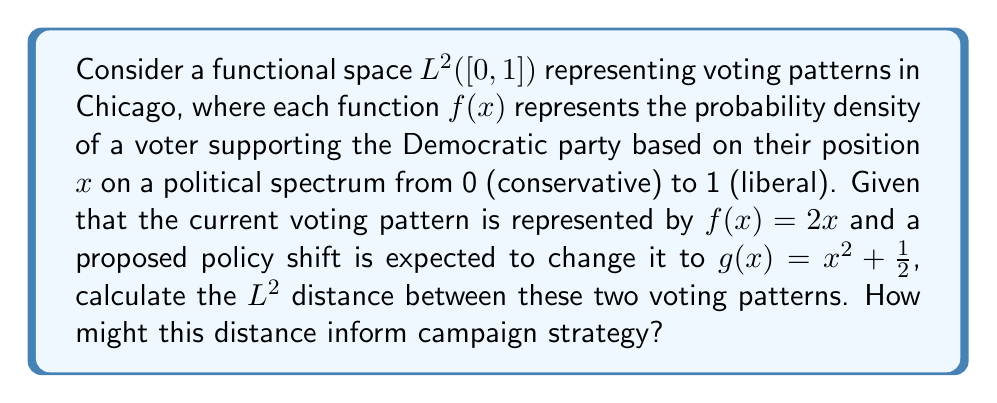What is the answer to this math problem? To solve this problem, we need to follow these steps:

1) The $L^2$ distance between two functions $f$ and $g$ in $L^2([0,1])$ is given by:

   $$\|f-g\|_2 = \sqrt{\int_0^1 |f(x) - g(x)|^2 dx}$$

2) In our case, $f(x) = 2x$ and $g(x) = x^2 + \frac{1}{2}$. So we need to calculate:

   $$\|f-g\|_2 = \sqrt{\int_0^1 |(2x) - (x^2 + \frac{1}{2})|^2 dx}$$

3) Let's simplify the integrand:
   
   $$(2x) - (x^2 + \frac{1}{2}) = 2x - x^2 - \frac{1}{2}$$

4) Now our integral becomes:

   $$\sqrt{\int_0^1 (2x - x^2 - \frac{1}{2})^2 dx}$$

5) Expand the squared term:

   $$\sqrt{\int_0^1 (4x^2 - 4x^3 - x + x^4 + x^2 + \frac{1}{4}) dx}$$

6) Simplify:

   $$\sqrt{\int_0^1 (x^4 - 4x^3 + 5x^2 - x + \frac{1}{4}) dx}$$

7) Integrate:

   $$\sqrt{[\frac{1}{5}x^5 - x^4 + \frac{5}{3}x^3 - \frac{1}{2}x^2 + \frac{1}{4}x]_0^1}$$

8) Evaluate the integral:

   $$\sqrt{(\frac{1}{5} - 1 + \frac{5}{3} - \frac{1}{2} + \frac{1}{4}) - (0 - 0 + 0 - 0 + 0)}$$

9) Simplify:

   $$\sqrt{\frac{1}{5} - 1 + \frac{5}{3} - \frac{1}{2} + \frac{1}{4}} = \sqrt{\frac{41}{60}} \approx 0.8272$$

This $L^2$ distance can inform campaign strategy by quantifying the magnitude of the shift in voting patterns. A smaller distance would indicate that the policy shift has a minor effect on voting patterns, while a larger distance (as in this case) suggests a more significant change. This could help in deciding whether to support or oppose the policy shift, or how to adjust campaign messaging to best respond to the expected change in voter preferences.
Answer: The $L^2$ distance between the two voting pattern functions is $\sqrt{\frac{41}{60}} \approx 0.8272$. 